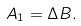Convert formula to latex. <formula><loc_0><loc_0><loc_500><loc_500>A _ { 1 } = \Delta B .</formula> 